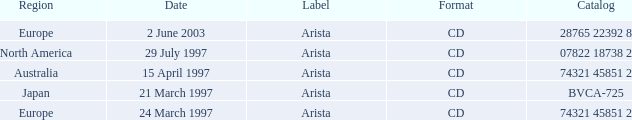What Date has the Region Europe and a Catalog of 74321 45851 2? 24 March 1997. 